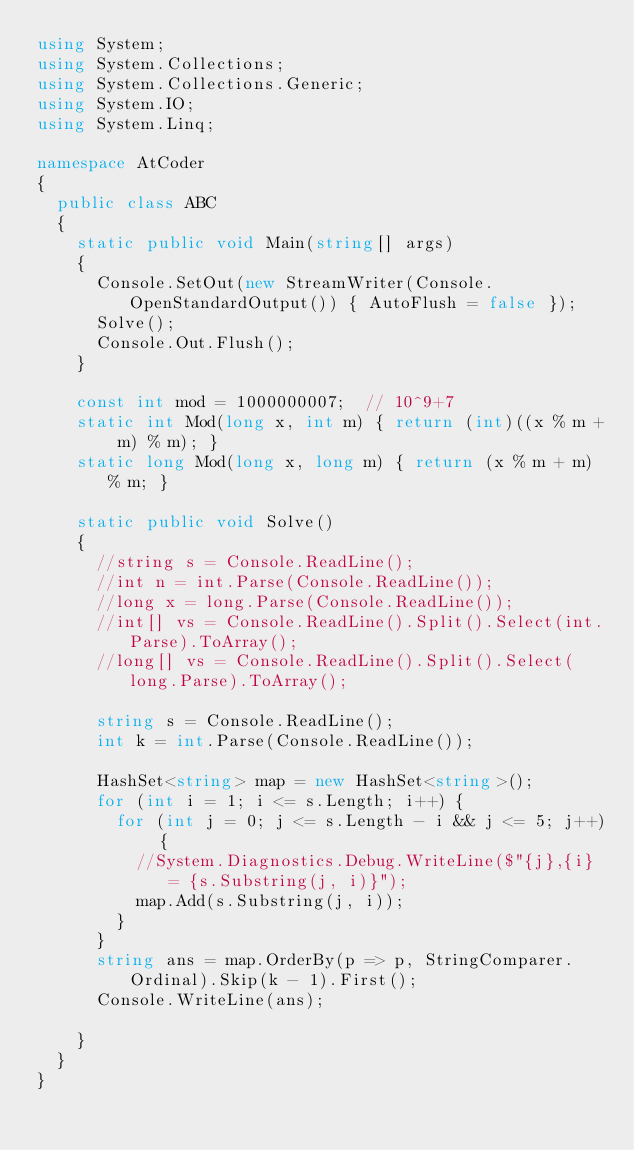<code> <loc_0><loc_0><loc_500><loc_500><_C#_>using System;
using System.Collections;
using System.Collections.Generic;
using System.IO;
using System.Linq;

namespace AtCoder
{
	public class ABC
	{
		static public void Main(string[] args)
		{
			Console.SetOut(new StreamWriter(Console.OpenStandardOutput()) { AutoFlush = false });
			Solve();
			Console.Out.Flush();
		}

		const int mod = 1000000007;  // 10^9+7
		static int Mod(long x, int m) { return (int)((x % m + m) % m); }
		static long Mod(long x, long m) { return (x % m + m) % m; }

		static public void Solve()
		{
			//string s = Console.ReadLine();
			//int n = int.Parse(Console.ReadLine());
			//long x = long.Parse(Console.ReadLine());
			//int[] vs = Console.ReadLine().Split().Select(int.Parse).ToArray();
			//long[] vs = Console.ReadLine().Split().Select(long.Parse).ToArray();

			string s = Console.ReadLine();
			int k = int.Parse(Console.ReadLine());

			HashSet<string> map = new HashSet<string>();
			for (int i = 1; i <= s.Length; i++) {
				for (int j = 0; j <= s.Length - i && j <= 5; j++) {
					//System.Diagnostics.Debug.WriteLine($"{j},{i} = {s.Substring(j, i)}");
					map.Add(s.Substring(j, i));
				}
			}
			string ans = map.OrderBy(p => p, StringComparer.Ordinal).Skip(k - 1).First();
			Console.WriteLine(ans);

		}
	}
}</code> 